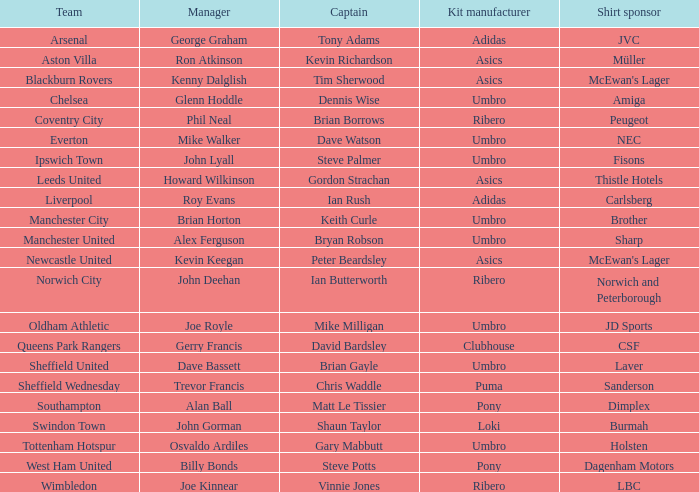Which unit has george graham as the supervisor? Arsenal. 